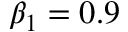<formula> <loc_0><loc_0><loc_500><loc_500>\beta _ { 1 } = 0 . 9</formula> 